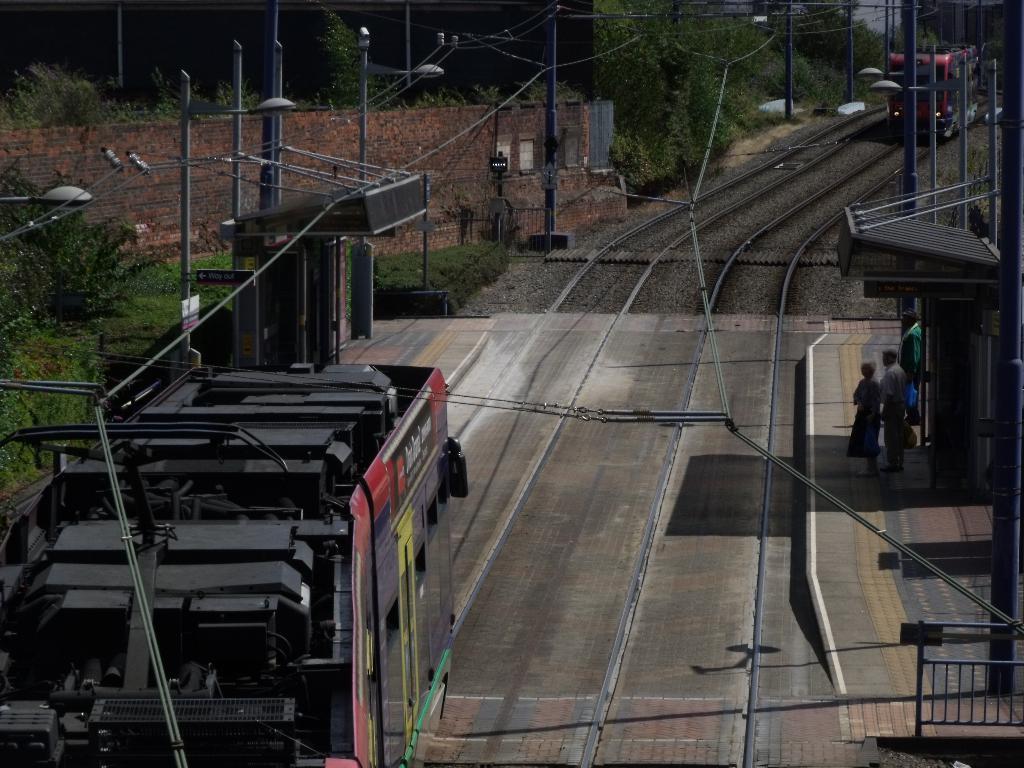Can you describe this image briefly? In the foreground of this picture, there is a train moving on the track and on either side there is platform. An another train coming in the opposite direction on the track. In the background, there are trees and poles. 